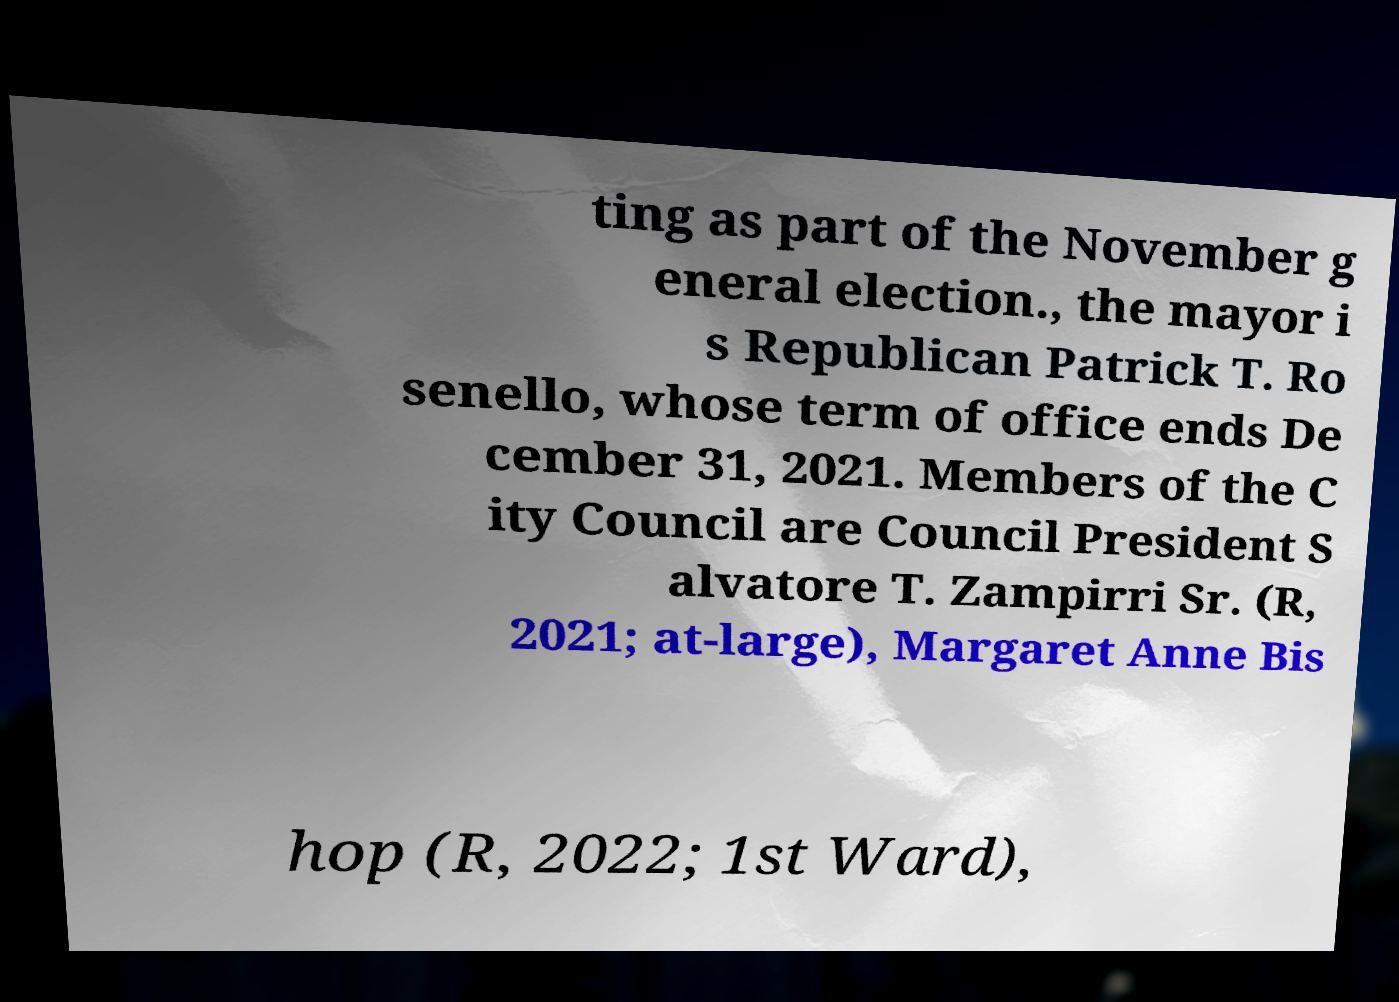Could you extract and type out the text from this image? ting as part of the November g eneral election., the mayor i s Republican Patrick T. Ro senello, whose term of office ends De cember 31, 2021. Members of the C ity Council are Council President S alvatore T. Zampirri Sr. (R, 2021; at-large), Margaret Anne Bis hop (R, 2022; 1st Ward), 